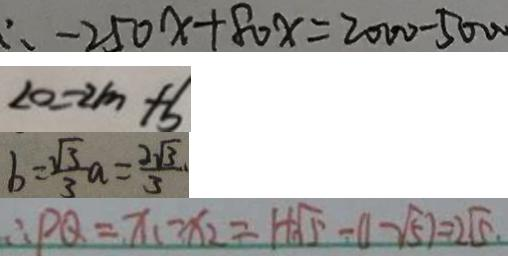Convert formula to latex. <formula><loc_0><loc_0><loc_500><loc_500>\therefore - 2 5 0 x + 8 0 x = 2 0 0 0 - 5 0 0 0 
 2 0 = 2 m + b 
 b = \frac { \sqrt { 3 } } { 3 } a = \frac { 2 \sqrt { 3 } } { 3 } 
 \therefore P Q = x _ { 1 } - x _ { 2 } = 1 + \sqrt { 5 } - ( 1 - \sqrt { 5 } ) = 2 \sqrt { 5 } .</formula> 